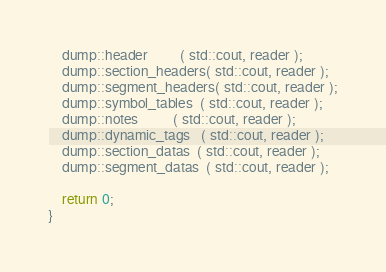Convert code to text. <code><loc_0><loc_0><loc_500><loc_500><_C++_>    dump::header         ( std::cout, reader );
    dump::section_headers( std::cout, reader );
    dump::segment_headers( std::cout, reader );
    dump::symbol_tables  ( std::cout, reader );
    dump::notes          ( std::cout, reader );
    dump::dynamic_tags   ( std::cout, reader );
    dump::section_datas  ( std::cout, reader );
    dump::segment_datas  ( std::cout, reader );

    return 0;
}
</code> 